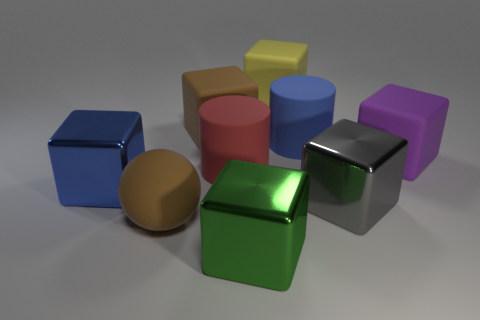Is the color of the big rubber sphere the same as the rubber cube that is on the left side of the big green metal cube?
Keep it short and to the point. Yes. What is the color of the large block right of the big gray thing?
Keep it short and to the point. Purple. There is a large blue rubber thing; are there any big yellow matte things on the right side of it?
Give a very brief answer. No. Are there more big shiny cubes than yellow rubber cubes?
Your answer should be compact. Yes. There is a rubber thing in front of the big shiny cube to the left of the large matte cylinder that is on the left side of the big green shiny block; what is its color?
Your answer should be compact. Brown. There is a large ball that is the same material as the big red cylinder; what is its color?
Offer a terse response. Brown. What number of things are either large cubes that are on the left side of the large purple matte block or metallic blocks behind the big matte ball?
Your response must be concise. 5. What color is the other large thing that is the same shape as the big red rubber thing?
Keep it short and to the point. Blue. Are there more big metallic objects behind the yellow rubber object than big blue shiny things that are on the left side of the big brown cube?
Keep it short and to the point. No. There is a brown rubber thing behind the rubber cylinder that is to the left of the big cylinder behind the purple object; what is its size?
Your response must be concise. Large. 